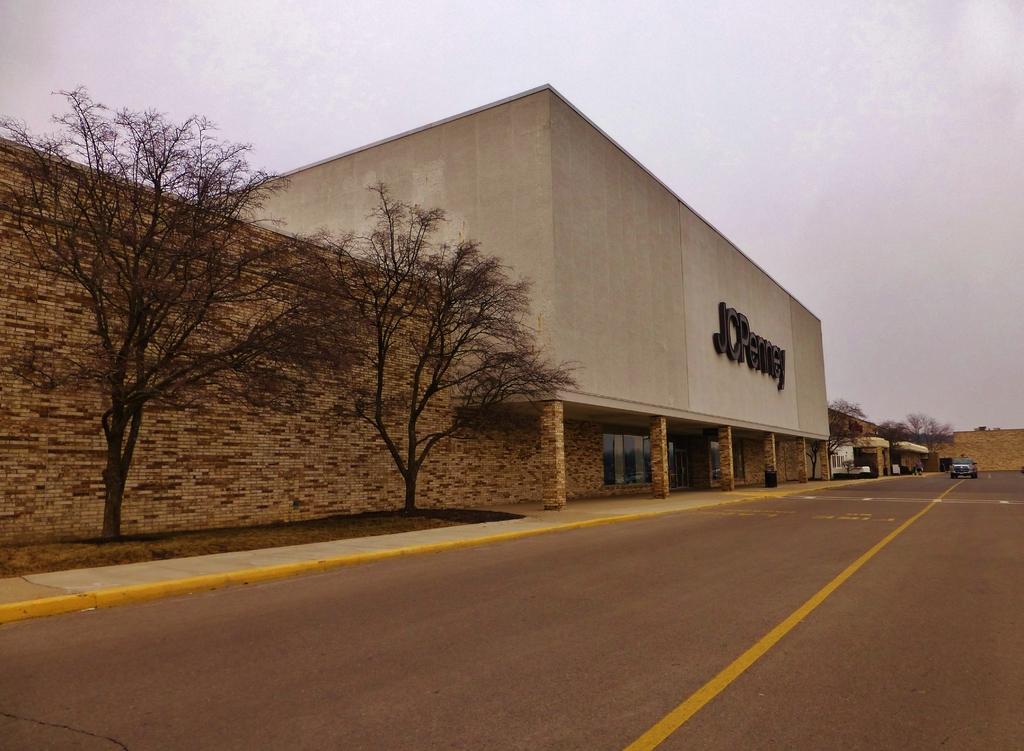Describe this image in one or two sentences. There is road on which, there is a vehicle. On the left side, there is a footpath, near two trees and grass on the ground. Beside the trees, there is a wall. There is a building which is having hoarding. In the background, there are buildings, trees, wall and clouds in the sky. 